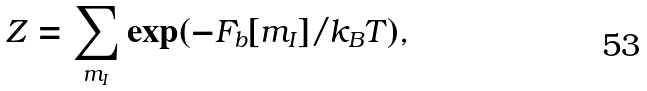Convert formula to latex. <formula><loc_0><loc_0><loc_500><loc_500>Z = \sum _ { m _ { I } } \exp ( - F _ { b } [ m _ { I } ] / k _ { B } T ) ,</formula> 